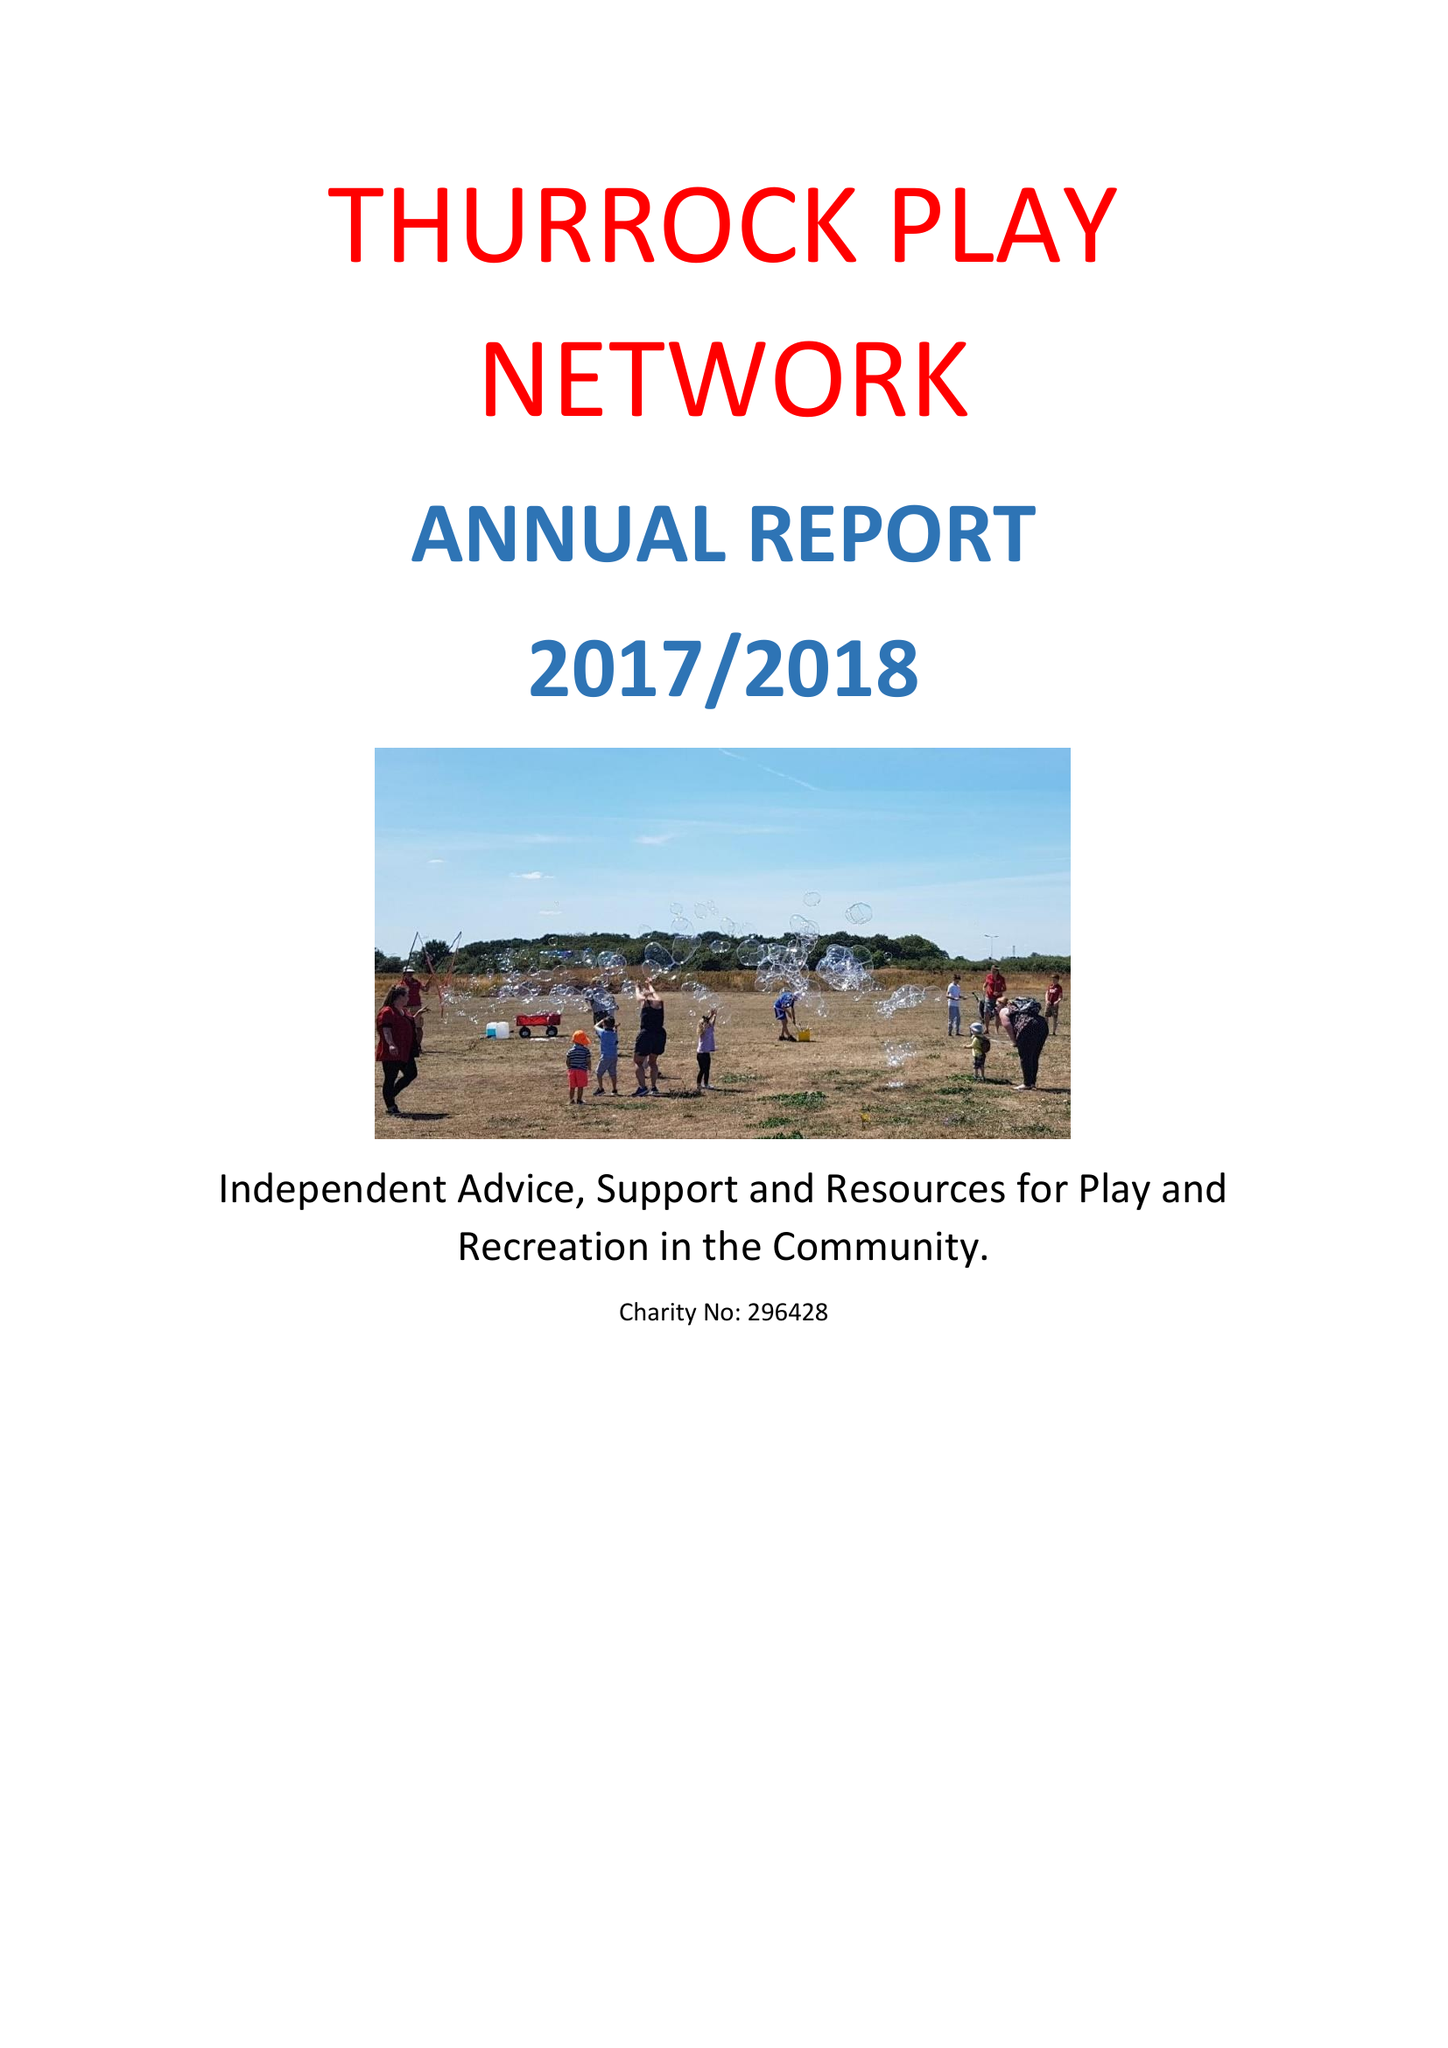What is the value for the charity_number?
Answer the question using a single word or phrase. 296428 